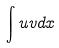<formula> <loc_0><loc_0><loc_500><loc_500>\int u v d x</formula> 